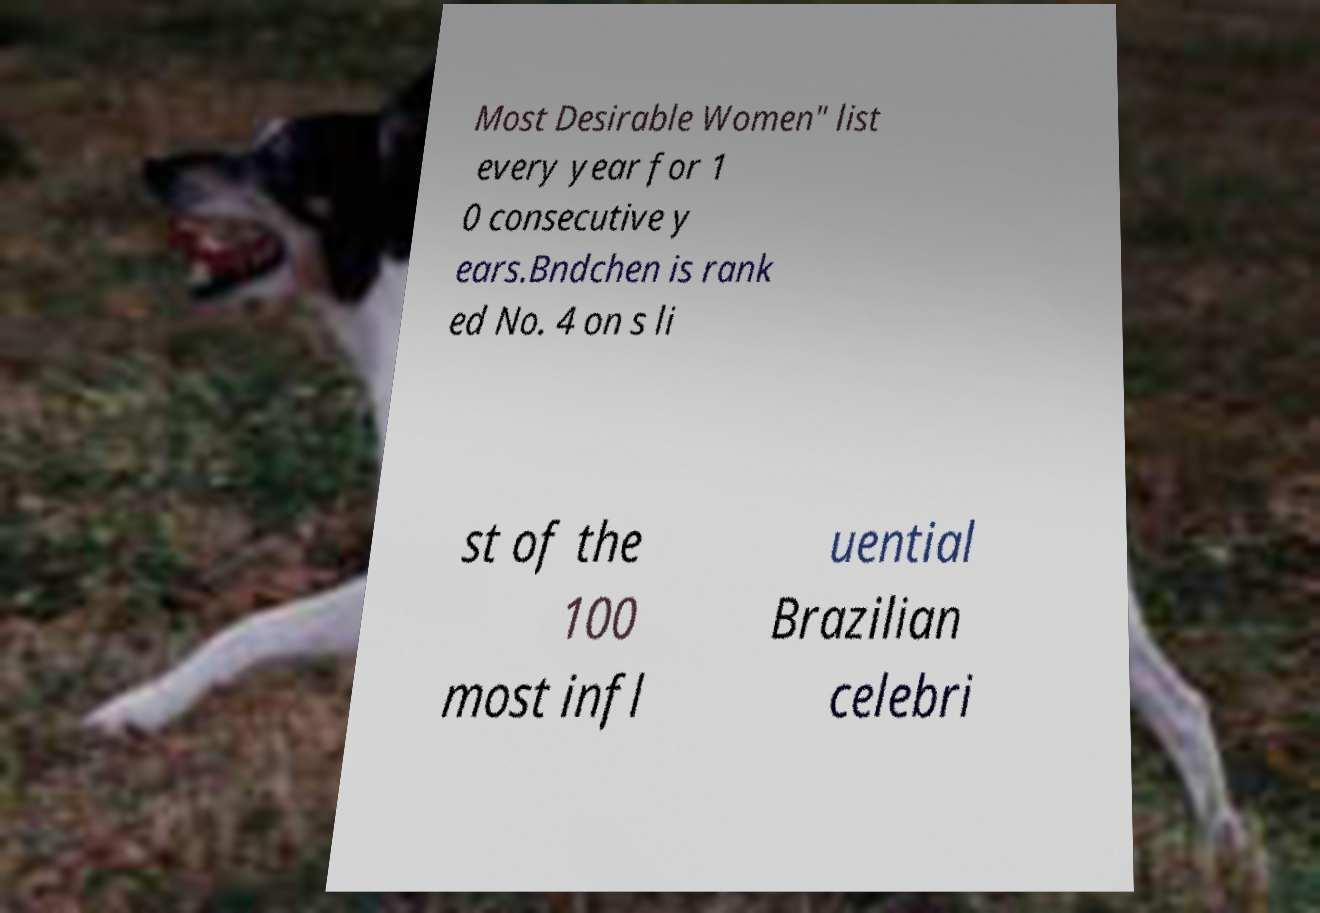Could you extract and type out the text from this image? Most Desirable Women" list every year for 1 0 consecutive y ears.Bndchen is rank ed No. 4 on s li st of the 100 most infl uential Brazilian celebri 